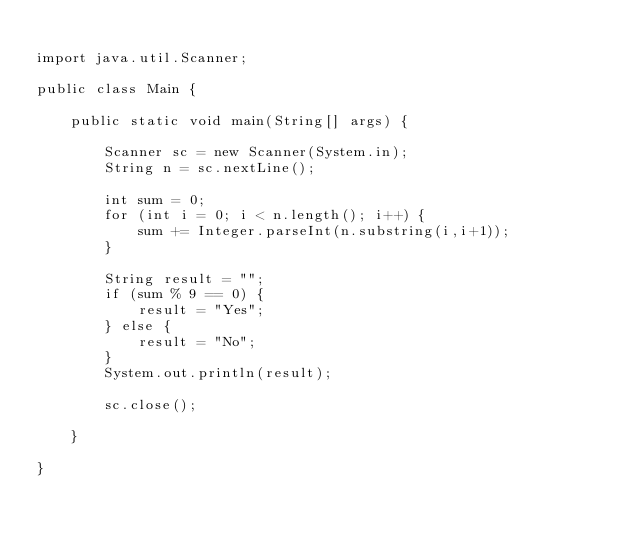Convert code to text. <code><loc_0><loc_0><loc_500><loc_500><_Java_>
import java.util.Scanner;

public class Main {

	public static void main(String[] args) {

		Scanner sc = new Scanner(System.in);
		String n = sc.nextLine();

		int sum = 0;
		for (int i = 0; i < n.length(); i++) {
			sum += Integer.parseInt(n.substring(i,i+1));
		}

		String result = "";
		if (sum % 9 == 0) {
			result = "Yes";
		} else {
			result = "No";
		}
		System.out.println(result);

		sc.close();

	}

}
</code> 